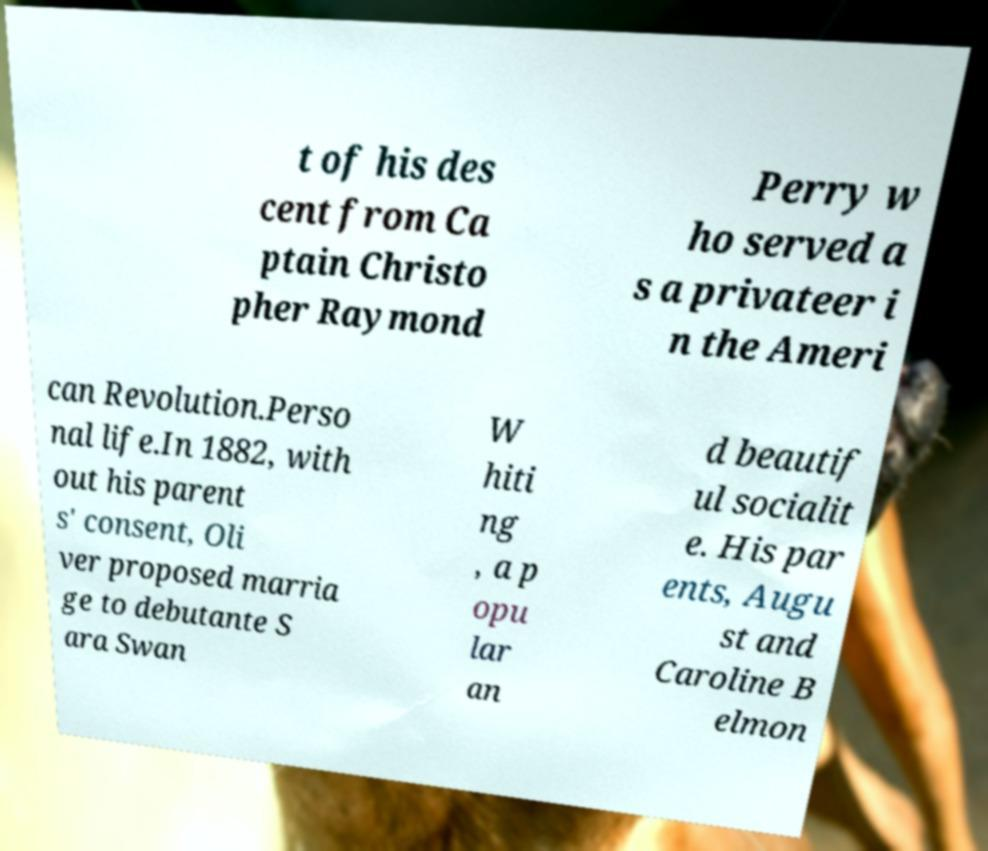Please read and relay the text visible in this image. What does it say? t of his des cent from Ca ptain Christo pher Raymond Perry w ho served a s a privateer i n the Ameri can Revolution.Perso nal life.In 1882, with out his parent s' consent, Oli ver proposed marria ge to debutante S ara Swan W hiti ng , a p opu lar an d beautif ul socialit e. His par ents, Augu st and Caroline B elmon 